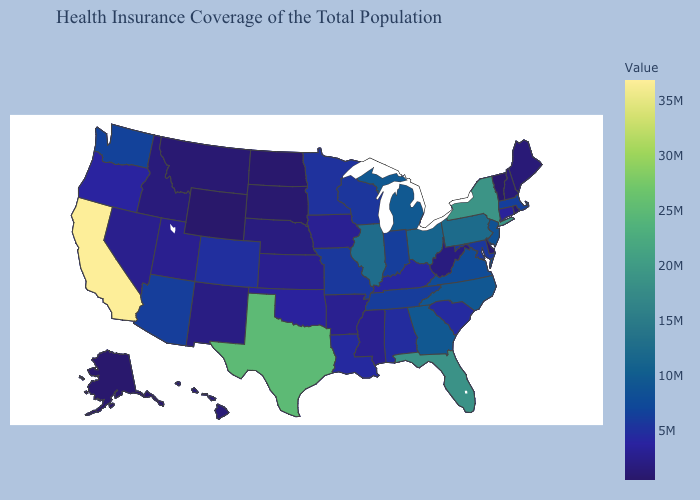Among the states that border Louisiana , does Mississippi have the highest value?
Keep it brief. No. Does Wyoming have the lowest value in the USA?
Short answer required. Yes. Among the states that border Maine , which have the lowest value?
Write a very short answer. New Hampshire. Among the states that border Virginia , does North Carolina have the highest value?
Quick response, please. Yes. Does the map have missing data?
Be succinct. No. 